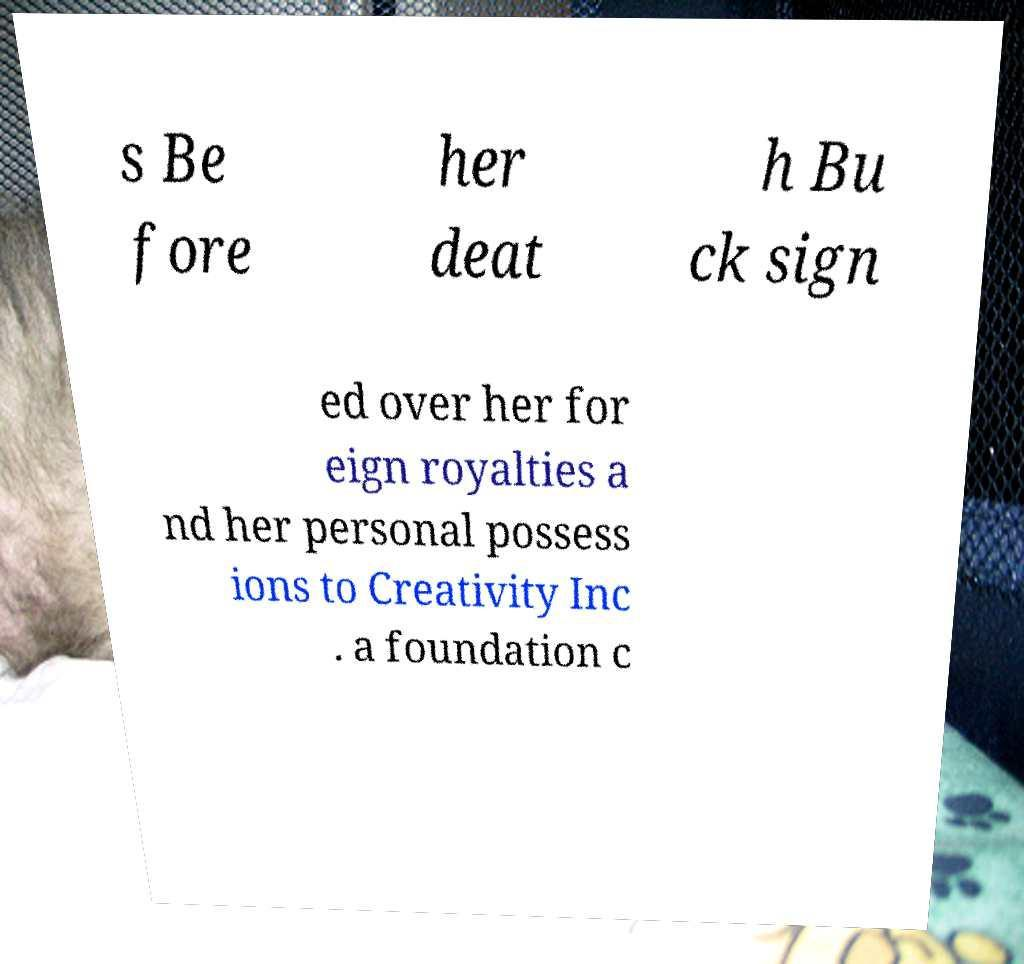What messages or text are displayed in this image? I need them in a readable, typed format. s Be fore her deat h Bu ck sign ed over her for eign royalties a nd her personal possess ions to Creativity Inc . a foundation c 